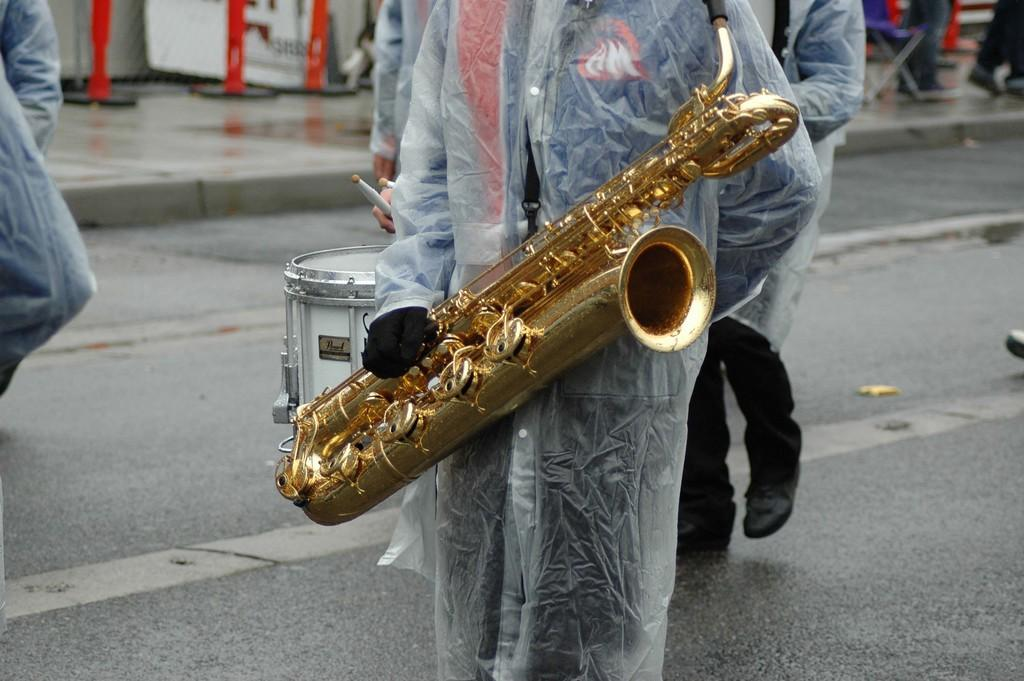How many people are in the image? There are persons in the image. What are the persons wearing in the image? The persons are wearing coats. What are the persons holding in the image? The persons are holding musical instruments. Can you see any beetles in the image? There are no beetles present in the image. How many fingers does the person on the left have in the image? The image does not provide enough detail to count the fingers of the person on the left. 